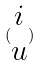Convert formula to latex. <formula><loc_0><loc_0><loc_500><loc_500>( \begin{matrix} i \\ u \end{matrix} )</formula> 